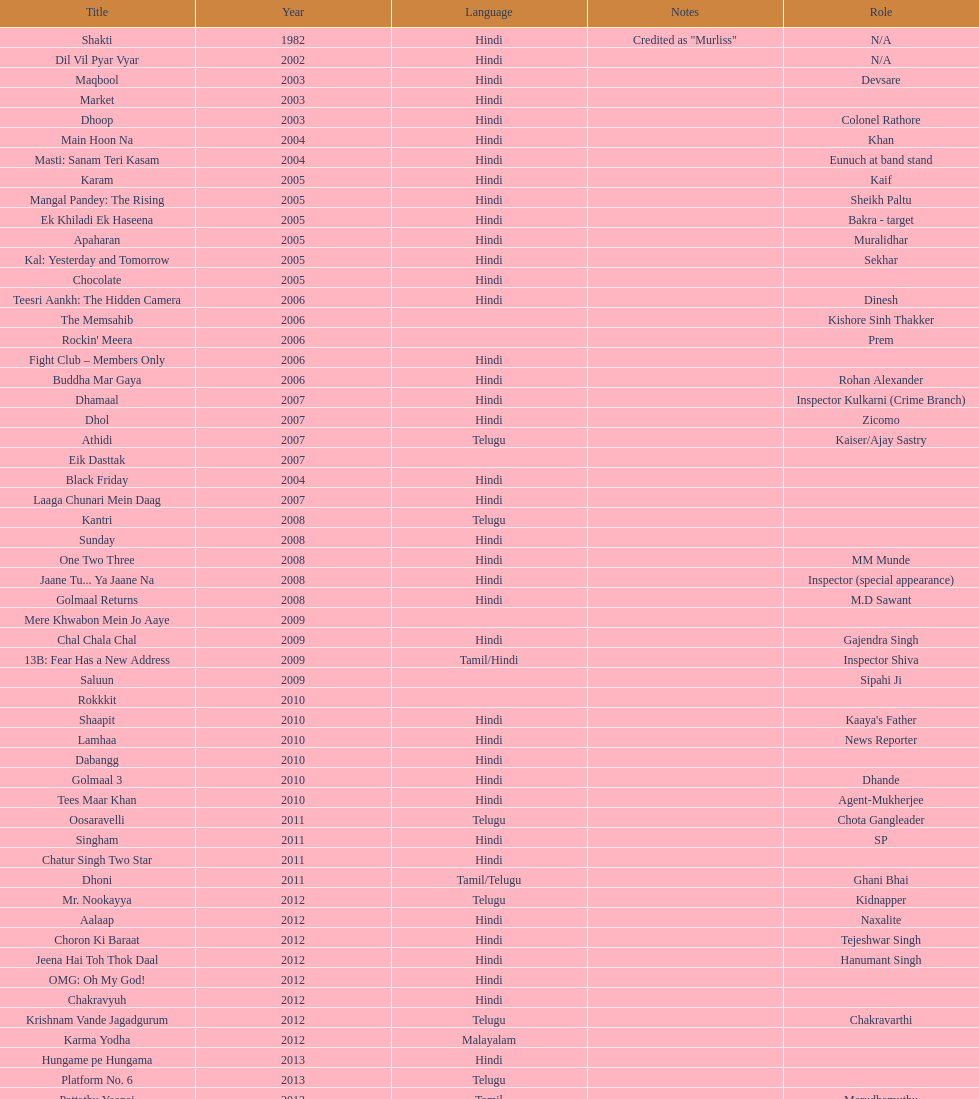What is the total years on the chart 13. 